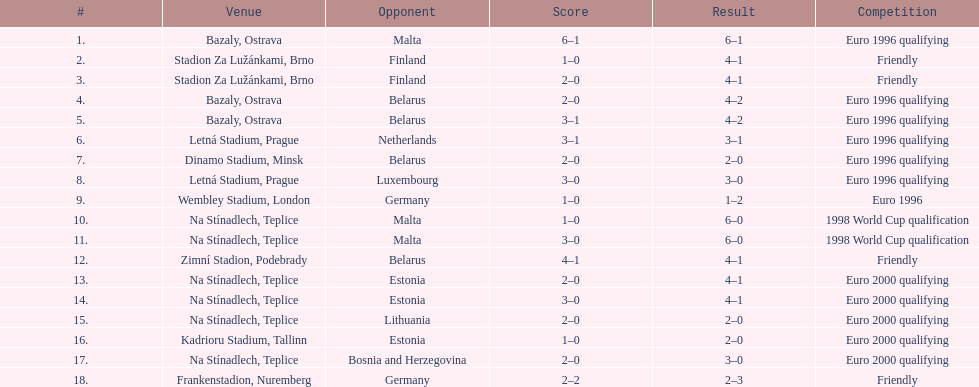How many games took place in ostrava? 2. 